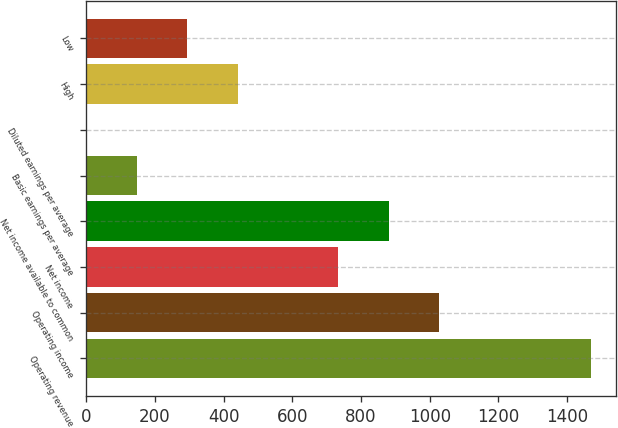<chart> <loc_0><loc_0><loc_500><loc_500><bar_chart><fcel>Operating revenue<fcel>Operating income<fcel>Net income<fcel>Net income available to common<fcel>Basic earnings per average<fcel>Diluted earnings per average<fcel>High<fcel>Low<nl><fcel>1468<fcel>1027.69<fcel>734.15<fcel>880.92<fcel>147.07<fcel>0.3<fcel>440.61<fcel>293.84<nl></chart> 